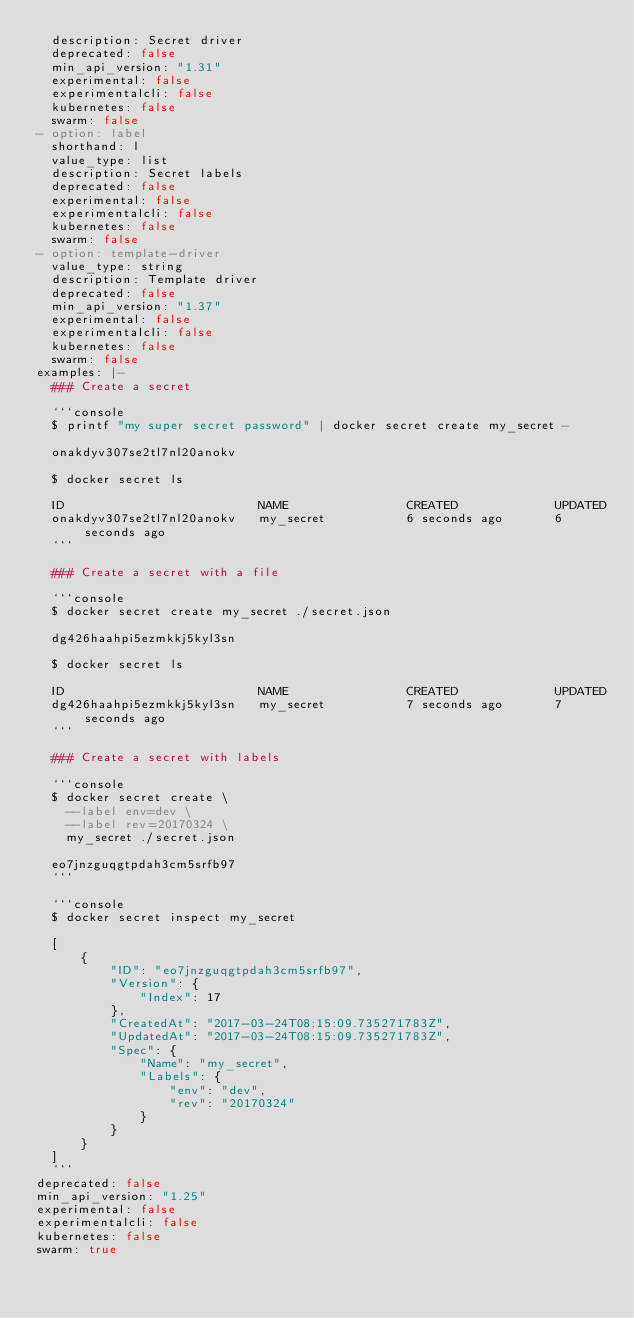<code> <loc_0><loc_0><loc_500><loc_500><_YAML_>  description: Secret driver
  deprecated: false
  min_api_version: "1.31"
  experimental: false
  experimentalcli: false
  kubernetes: false
  swarm: false
- option: label
  shorthand: l
  value_type: list
  description: Secret labels
  deprecated: false
  experimental: false
  experimentalcli: false
  kubernetes: false
  swarm: false
- option: template-driver
  value_type: string
  description: Template driver
  deprecated: false
  min_api_version: "1.37"
  experimental: false
  experimentalcli: false
  kubernetes: false
  swarm: false
examples: |-
  ### Create a secret

  ```console
  $ printf "my super secret password" | docker secret create my_secret -

  onakdyv307se2tl7nl20anokv

  $ docker secret ls

  ID                          NAME                CREATED             UPDATED
  onakdyv307se2tl7nl20anokv   my_secret           6 seconds ago       6 seconds ago
  ```

  ### Create a secret with a file

  ```console
  $ docker secret create my_secret ./secret.json

  dg426haahpi5ezmkkj5kyl3sn

  $ docker secret ls

  ID                          NAME                CREATED             UPDATED
  dg426haahpi5ezmkkj5kyl3sn   my_secret           7 seconds ago       7 seconds ago
  ```

  ### Create a secret with labels

  ```console
  $ docker secret create \
    --label env=dev \
    --label rev=20170324 \
    my_secret ./secret.json

  eo7jnzguqgtpdah3cm5srfb97
  ```

  ```console
  $ docker secret inspect my_secret

  [
      {
          "ID": "eo7jnzguqgtpdah3cm5srfb97",
          "Version": {
              "Index": 17
          },
          "CreatedAt": "2017-03-24T08:15:09.735271783Z",
          "UpdatedAt": "2017-03-24T08:15:09.735271783Z",
          "Spec": {
              "Name": "my_secret",
              "Labels": {
                  "env": "dev",
                  "rev": "20170324"
              }
          }
      }
  ]
  ```
deprecated: false
min_api_version: "1.25"
experimental: false
experimentalcli: false
kubernetes: false
swarm: true

</code> 